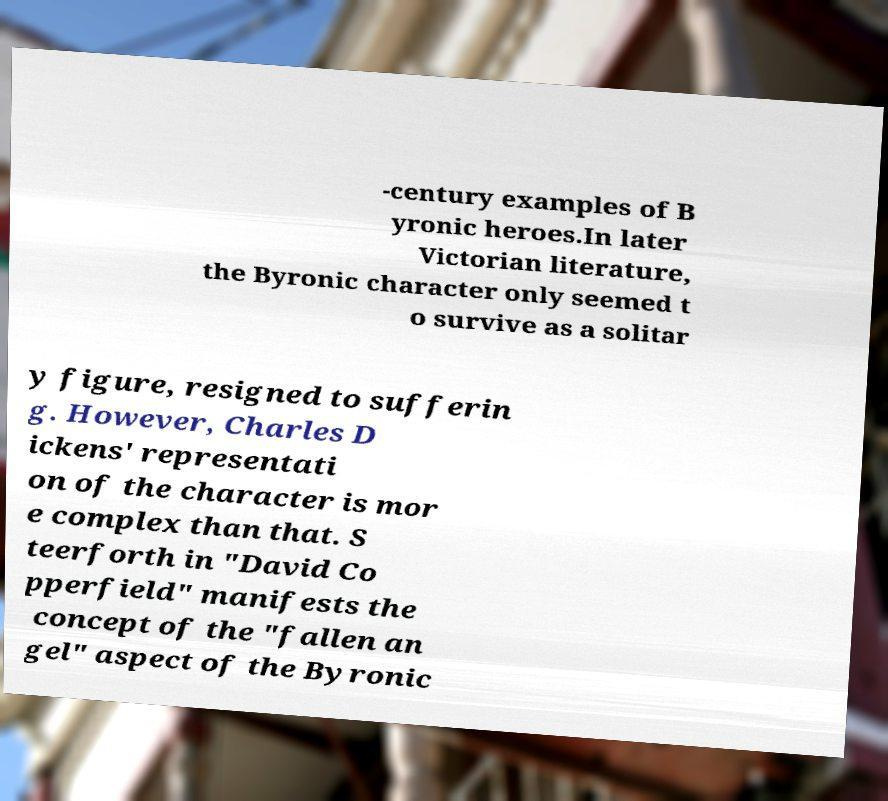For documentation purposes, I need the text within this image transcribed. Could you provide that? -century examples of B yronic heroes.In later Victorian literature, the Byronic character only seemed t o survive as a solitar y figure, resigned to sufferin g. However, Charles D ickens' representati on of the character is mor e complex than that. S teerforth in "David Co pperfield" manifests the concept of the "fallen an gel" aspect of the Byronic 